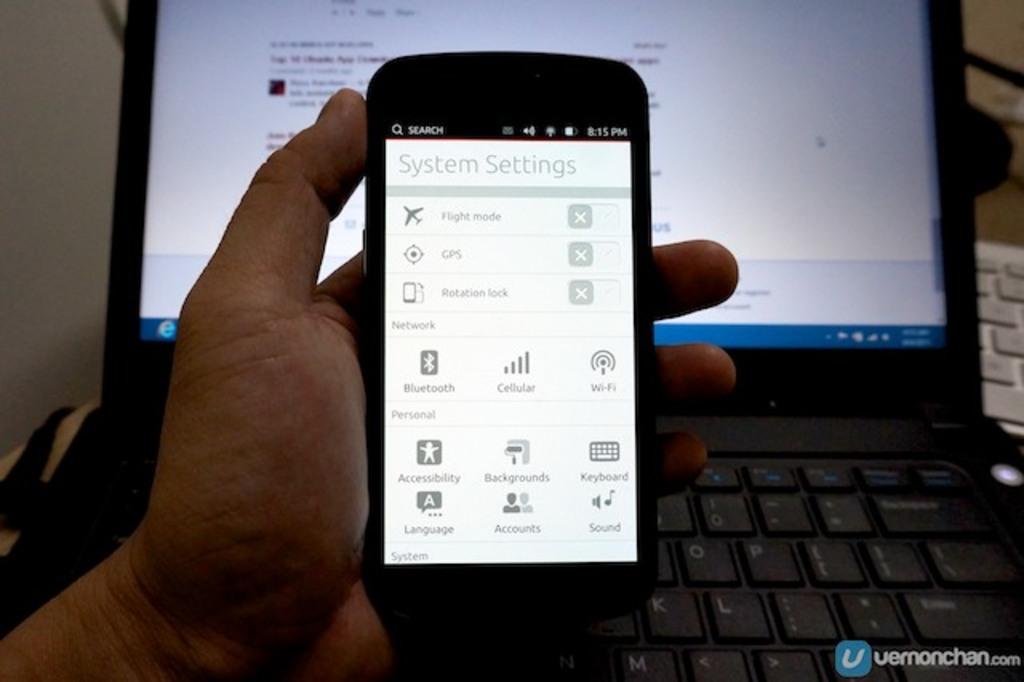What phone menu are they in?
Provide a short and direct response. System settings. What time is it?
Make the answer very short. 8:15 pm. 